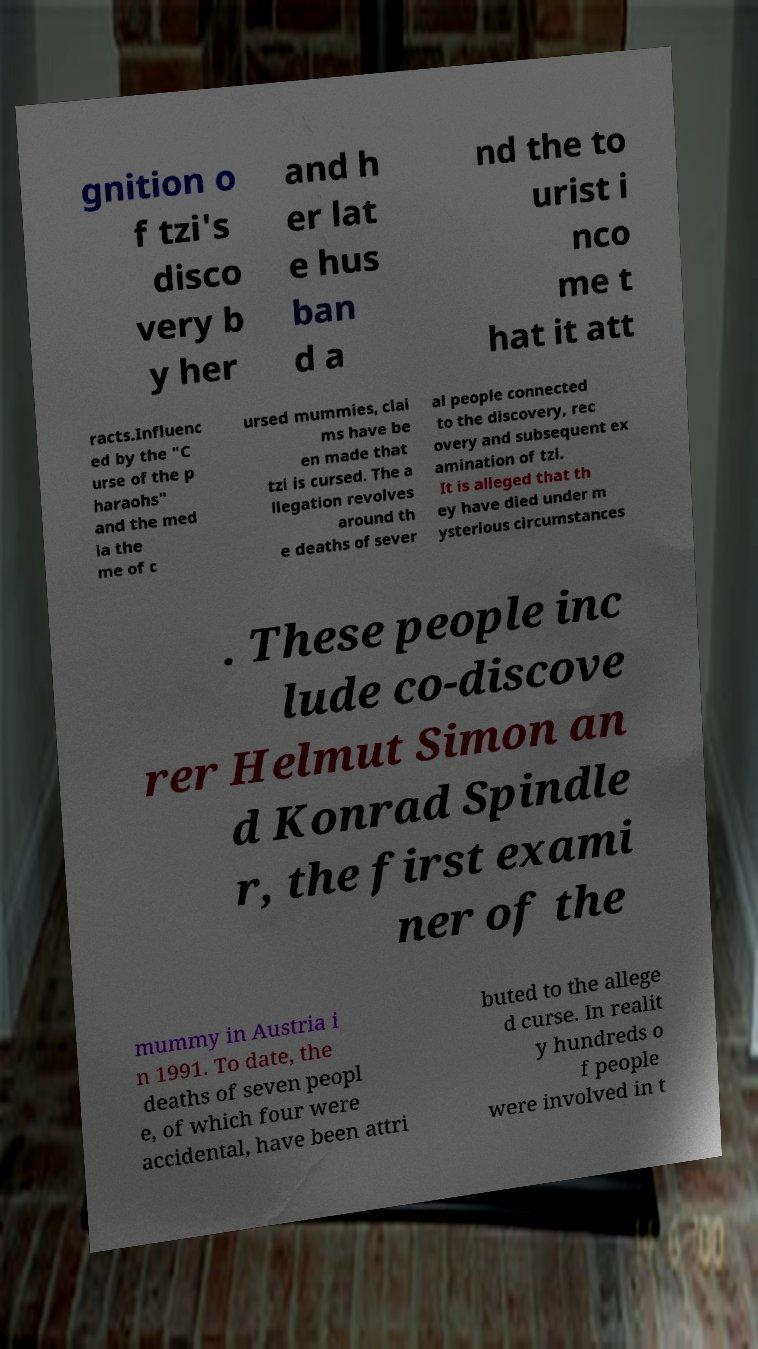Please identify and transcribe the text found in this image. gnition o f tzi's disco very b y her and h er lat e hus ban d a nd the to urist i nco me t hat it att racts.Influenc ed by the "C urse of the p haraohs" and the med ia the me of c ursed mummies, clai ms have be en made that tzi is cursed. The a llegation revolves around th e deaths of sever al people connected to the discovery, rec overy and subsequent ex amination of tzi. It is alleged that th ey have died under m ysterious circumstances . These people inc lude co-discove rer Helmut Simon an d Konrad Spindle r, the first exami ner of the mummy in Austria i n 1991. To date, the deaths of seven peopl e, of which four were accidental, have been attri buted to the allege d curse. In realit y hundreds o f people were involved in t 